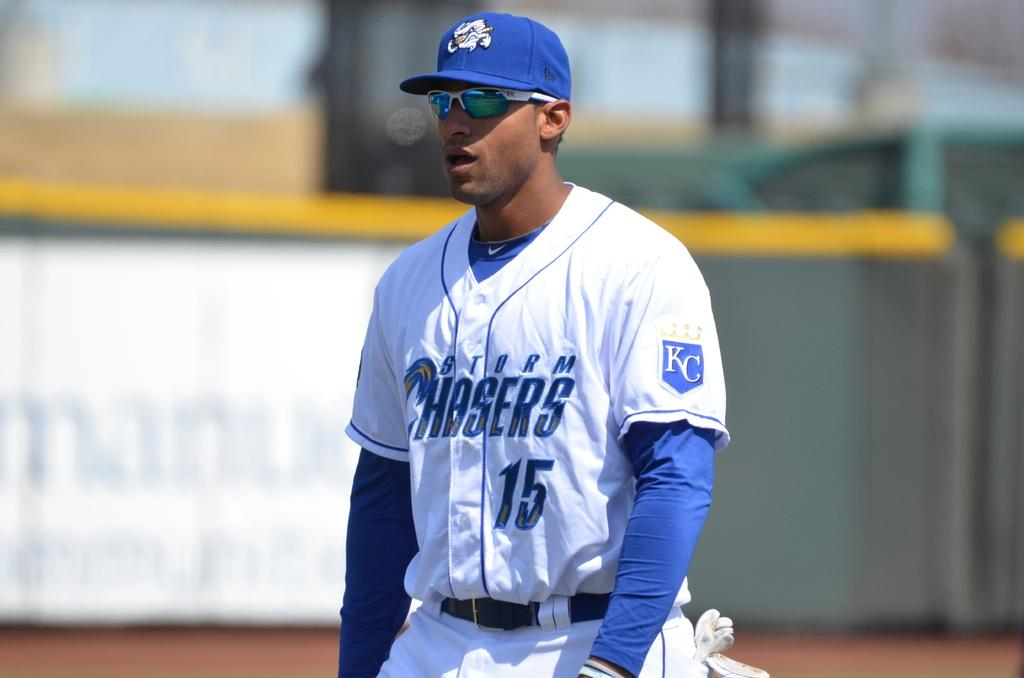What is the main subject of the image? There is a person standing in the middle of the image. What is the person wearing? The person is wearing a white dress and a blue cap. What can be seen in the background of the image? There is a wall in the background of the image. What type of oil can be seen dripping from the person's cap in the image? There is no oil present in the image, and the person's cap is not dripping. What type of work does the secretary do in the image? There is no secretary present in the image, and the person's occupation is not mentioned. 